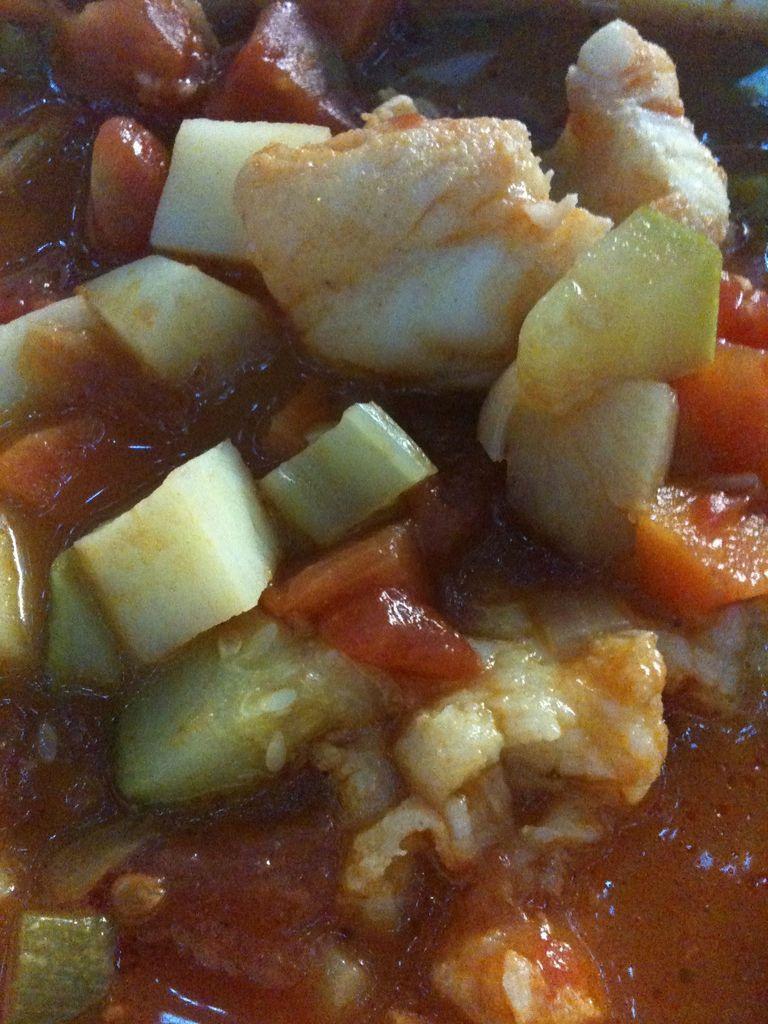In one or two sentences, can you explain what this image depicts? In this image we can see food items, there are vegetables in it. 